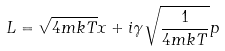Convert formula to latex. <formula><loc_0><loc_0><loc_500><loc_500>L = \sqrt { 4 m k T } x + i \gamma \sqrt { \frac { 1 } { 4 m k T } } p</formula> 